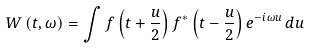Convert formula to latex. <formula><loc_0><loc_0><loc_500><loc_500>W \left ( t , \omega \right ) = \int f \left ( t + \frac { u } { 2 } \right ) f ^ { * } \left ( t - \frac { u } { 2 } \right ) e ^ { - i \omega u } \, d u \,</formula> 